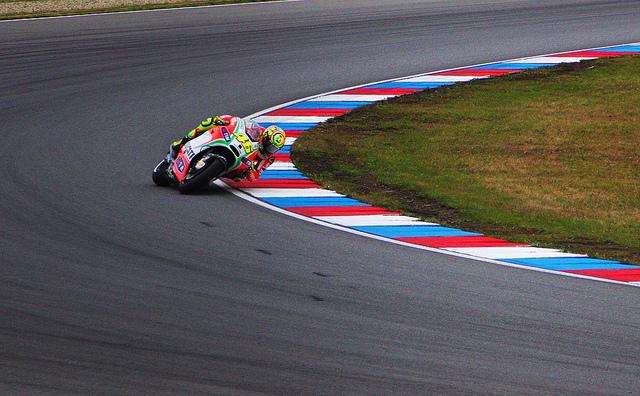What colors are between the track and grass?
Short answer required. Red, white, and blue. What is the person riding?
Answer briefly. Motorcycle. What is the person wearing on his head?
Answer briefly. Helmet. 